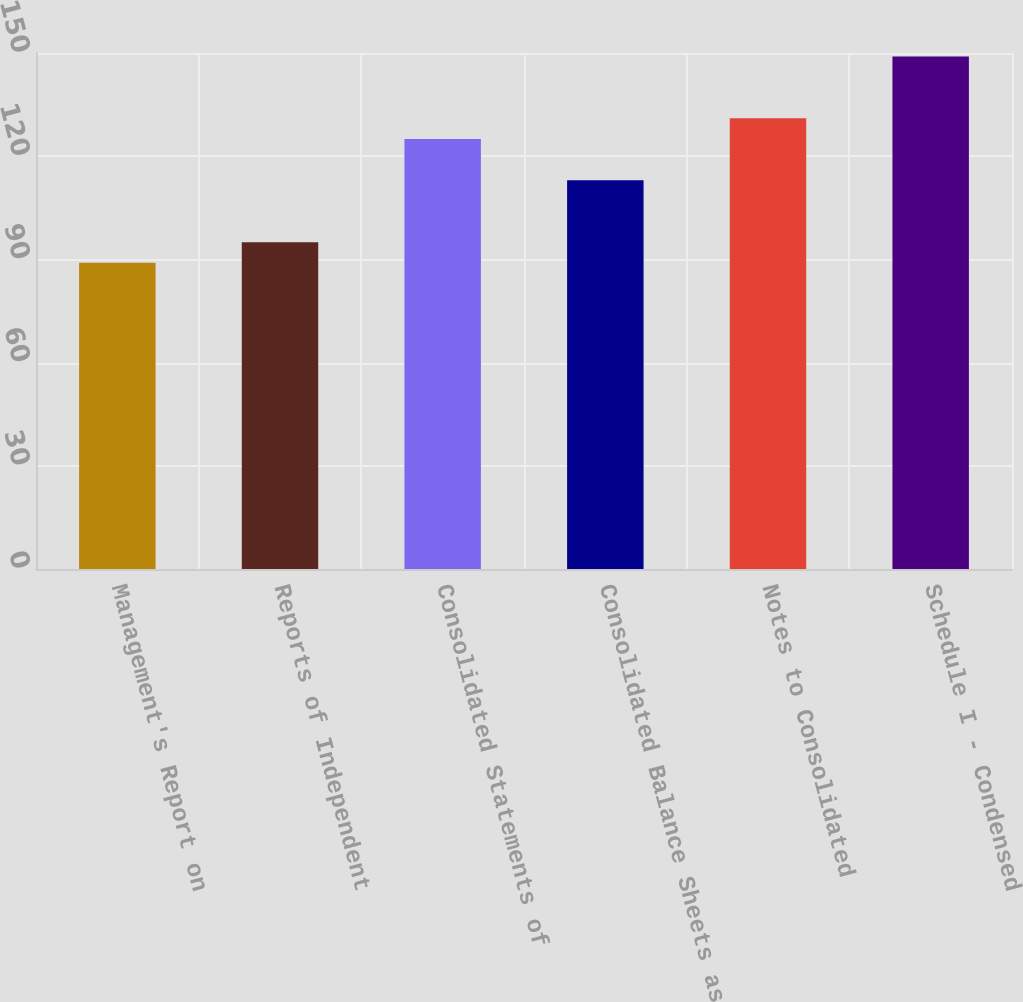Convert chart to OTSL. <chart><loc_0><loc_0><loc_500><loc_500><bar_chart><fcel>Management's Report on<fcel>Reports of Independent<fcel>Consolidated Statements of<fcel>Consolidated Balance Sheets as<fcel>Notes to Consolidated<fcel>Schedule I - Condensed<nl><fcel>89<fcel>95<fcel>125<fcel>113<fcel>131<fcel>149<nl></chart> 